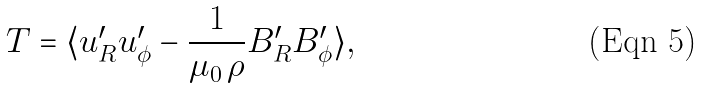<formula> <loc_0><loc_0><loc_500><loc_500>T = \langle u _ { R } ^ { \prime } u _ { \phi } ^ { \prime } - \frac { 1 } { \mu _ { 0 } \, \rho } B _ { R } ^ { \prime } B _ { \phi } ^ { \prime } \rangle ,</formula> 